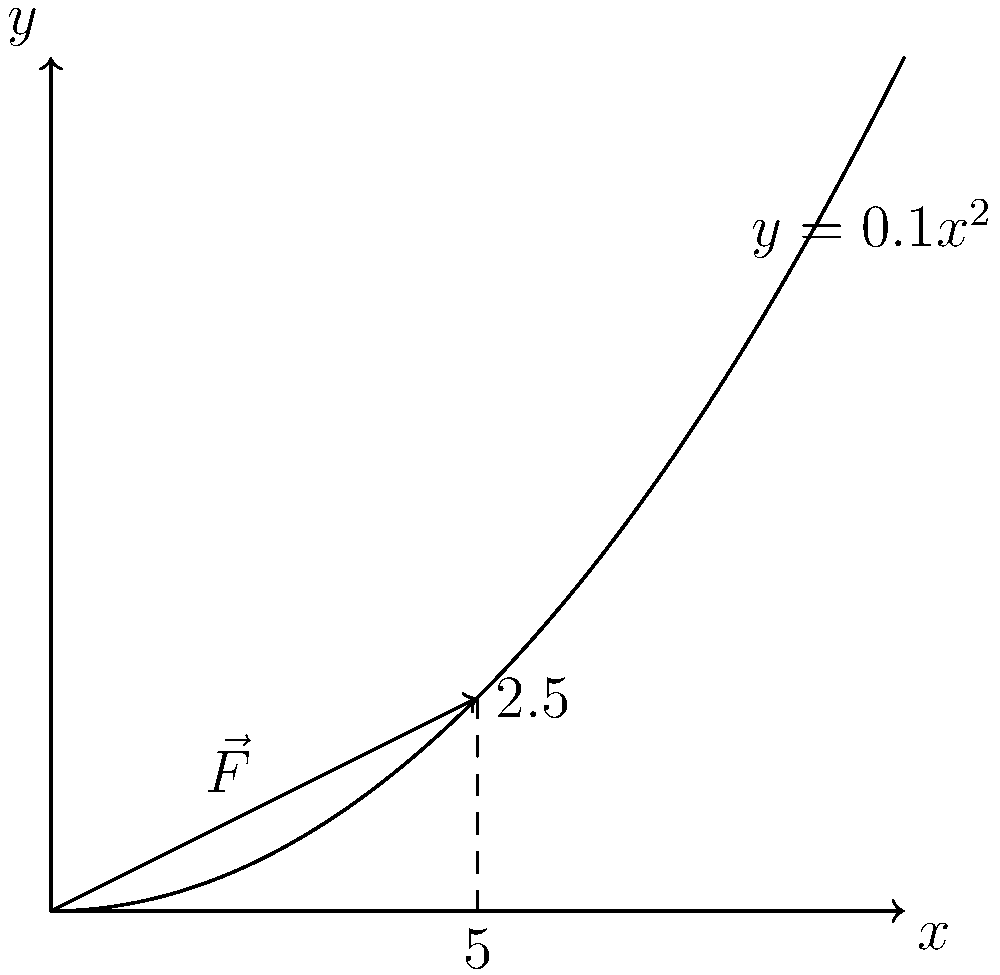As a financial advisor, you're explaining the concept of compound interest to a client using a physics analogy. Consider a force $\vec{F} = (2\text{ N}, 1\text{ N})$ acting on an object as it moves along the path $y = 0.1x^2$ from $x = 0$ to $x = 5$ meters. Calculate the work done by this force, relating it to the growth of an investment over time. To calculate the work done by a force along a curved path, we use the line integral:

$$ W = \int_C \vec{F} \cdot d\vec{r} $$

Where $\vec{F}$ is the force and $d\vec{r}$ is the displacement vector.

Step 1: Express $d\vec{r}$ in terms of $x$
$$ y = 0.1x^2 $$
$$ \frac{dy}{dx} = 0.2x $$
$$ d\vec{r} = (dx, dy) = (dx, 0.2x \, dx) $$

Step 2: Calculate the dot product $\vec{F} \cdot d\vec{r}$
$$ \vec{F} \cdot d\vec{r} = (2, 1) \cdot (dx, 0.2x \, dx) = 2dx + 0.2x \, dx $$

Step 3: Set up the integral
$$ W = \int_0^5 (2 + 0.2x) \, dx $$

Step 4: Solve the integral
$$ W = [2x + 0.1x^2]_0^5 $$
$$ W = (10 + 2.5) - (0 + 0) = 12.5 \text{ J} $$

Relating this to finance: Just as the work increases non-linearly due to the curved path, compound interest causes investments to grow non-linearly over time, resulting in accelerated growth.
Answer: 12.5 J 